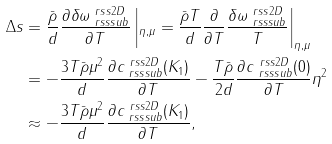<formula> <loc_0><loc_0><loc_500><loc_500>\Delta s & = \frac { \bar { \rho } } { d } \frac { \partial \delta \omega ^ { \ r s s 2 D } _ { \ r s s s u b } } { \partial T } \left | _ { \eta , \mu } = \frac { \bar { \rho } T } { d } \frac { \partial } { \partial T } \frac { \delta \omega ^ { \ r s s 2 D } _ { \ r s s s u b } } { T } \right | _ { \eta , \mu } \\ & = - \frac { 3 T \bar { \rho } \mu ^ { 2 } } { d } \frac { \partial c ^ { \ r s s 2 D } _ { \ r s s s u b } ( K _ { 1 } ) } { \partial T } - \frac { T \bar { \rho } } { 2 d } \frac { \partial c ^ { \ r s s 2 D } _ { \ r s s s u b } ( 0 ) } { \partial T } \eta ^ { 2 } \\ & \approx - \frac { 3 T \bar { \rho } \mu ^ { 2 } } { d } \frac { \partial c ^ { \ r s s 2 D } _ { \ r s s s u b } ( K _ { 1 } ) } { \partial T } ,</formula> 